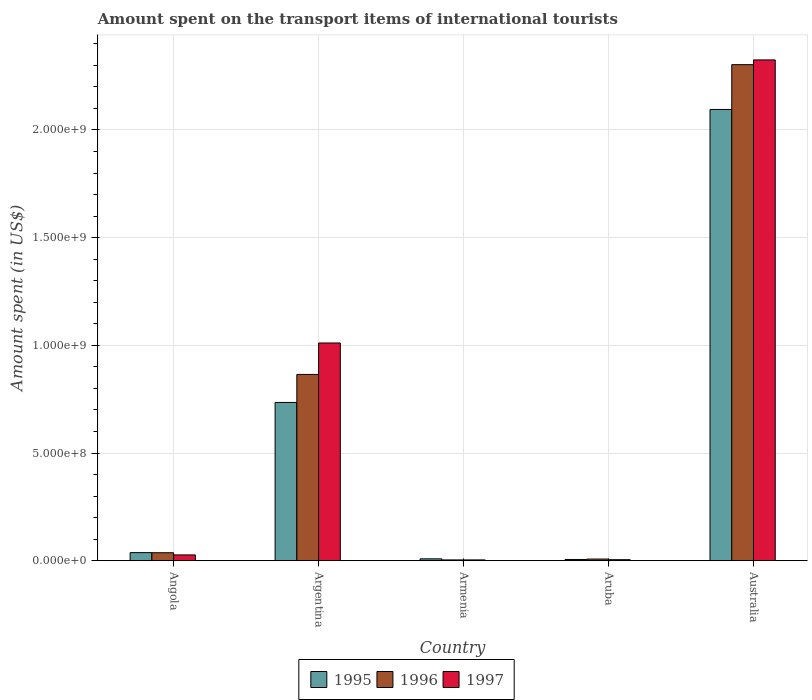How many different coloured bars are there?
Your response must be concise. 3. Are the number of bars on each tick of the X-axis equal?
Your answer should be very brief. Yes. How many bars are there on the 4th tick from the right?
Your answer should be compact. 3. What is the label of the 4th group of bars from the left?
Provide a succinct answer. Aruba. What is the amount spent on the transport items of international tourists in 1997 in Aruba?
Ensure brevity in your answer.  5.00e+06. Across all countries, what is the maximum amount spent on the transport items of international tourists in 1995?
Ensure brevity in your answer.  2.10e+09. Across all countries, what is the minimum amount spent on the transport items of international tourists in 1996?
Offer a terse response. 4.00e+06. In which country was the amount spent on the transport items of international tourists in 1995 minimum?
Provide a succinct answer. Aruba. What is the total amount spent on the transport items of international tourists in 1996 in the graph?
Ensure brevity in your answer.  3.22e+09. What is the difference between the amount spent on the transport items of international tourists in 1995 in Argentina and that in Aruba?
Offer a terse response. 7.29e+08. What is the difference between the amount spent on the transport items of international tourists in 1995 in Armenia and the amount spent on the transport items of international tourists in 1996 in Angola?
Keep it short and to the point. -2.84e+07. What is the average amount spent on the transport items of international tourists in 1996 per country?
Provide a short and direct response. 6.43e+08. What is the difference between the amount spent on the transport items of international tourists of/in 1996 and amount spent on the transport items of international tourists of/in 1995 in Armenia?
Provide a short and direct response. -5.00e+06. In how many countries, is the amount spent on the transport items of international tourists in 1995 greater than 2000000000 US$?
Offer a terse response. 1. What is the ratio of the amount spent on the transport items of international tourists in 1995 in Argentina to that in Armenia?
Your response must be concise. 81.67. Is the amount spent on the transport items of international tourists in 1997 in Angola less than that in Armenia?
Your response must be concise. No. What is the difference between the highest and the second highest amount spent on the transport items of international tourists in 1995?
Keep it short and to the point. 2.06e+09. What is the difference between the highest and the lowest amount spent on the transport items of international tourists in 1995?
Offer a very short reply. 2.09e+09. In how many countries, is the amount spent on the transport items of international tourists in 1995 greater than the average amount spent on the transport items of international tourists in 1995 taken over all countries?
Provide a succinct answer. 2. What does the 1st bar from the left in Aruba represents?
Ensure brevity in your answer.  1995. Is it the case that in every country, the sum of the amount spent on the transport items of international tourists in 1996 and amount spent on the transport items of international tourists in 1997 is greater than the amount spent on the transport items of international tourists in 1995?
Keep it short and to the point. No. Are all the bars in the graph horizontal?
Keep it short and to the point. No. How many countries are there in the graph?
Your answer should be compact. 5. What is the difference between two consecutive major ticks on the Y-axis?
Provide a short and direct response. 5.00e+08. Where does the legend appear in the graph?
Make the answer very short. Bottom center. How many legend labels are there?
Your answer should be very brief. 3. How are the legend labels stacked?
Provide a succinct answer. Horizontal. What is the title of the graph?
Offer a very short reply. Amount spent on the transport items of international tourists. Does "1967" appear as one of the legend labels in the graph?
Give a very brief answer. No. What is the label or title of the X-axis?
Make the answer very short. Country. What is the label or title of the Y-axis?
Provide a short and direct response. Amount spent (in US$). What is the Amount spent (in US$) in 1995 in Angola?
Your response must be concise. 3.78e+07. What is the Amount spent (in US$) in 1996 in Angola?
Your response must be concise. 3.74e+07. What is the Amount spent (in US$) of 1997 in Angola?
Provide a succinct answer. 2.72e+07. What is the Amount spent (in US$) of 1995 in Argentina?
Ensure brevity in your answer.  7.35e+08. What is the Amount spent (in US$) of 1996 in Argentina?
Provide a succinct answer. 8.65e+08. What is the Amount spent (in US$) of 1997 in Argentina?
Make the answer very short. 1.01e+09. What is the Amount spent (in US$) in 1995 in Armenia?
Ensure brevity in your answer.  9.00e+06. What is the Amount spent (in US$) in 1996 in Armenia?
Offer a terse response. 4.00e+06. What is the Amount spent (in US$) in 1995 in Aruba?
Offer a very short reply. 6.00e+06. What is the Amount spent (in US$) of 1996 in Aruba?
Keep it short and to the point. 8.00e+06. What is the Amount spent (in US$) of 1995 in Australia?
Offer a terse response. 2.10e+09. What is the Amount spent (in US$) in 1996 in Australia?
Provide a succinct answer. 2.30e+09. What is the Amount spent (in US$) of 1997 in Australia?
Provide a short and direct response. 2.32e+09. Across all countries, what is the maximum Amount spent (in US$) in 1995?
Your response must be concise. 2.10e+09. Across all countries, what is the maximum Amount spent (in US$) in 1996?
Your answer should be very brief. 2.30e+09. Across all countries, what is the maximum Amount spent (in US$) in 1997?
Give a very brief answer. 2.32e+09. Across all countries, what is the minimum Amount spent (in US$) of 1995?
Your response must be concise. 6.00e+06. Across all countries, what is the minimum Amount spent (in US$) of 1996?
Your answer should be very brief. 4.00e+06. Across all countries, what is the minimum Amount spent (in US$) of 1997?
Ensure brevity in your answer.  4.00e+06. What is the total Amount spent (in US$) of 1995 in the graph?
Offer a very short reply. 2.88e+09. What is the total Amount spent (in US$) of 1996 in the graph?
Ensure brevity in your answer.  3.22e+09. What is the total Amount spent (in US$) of 1997 in the graph?
Offer a terse response. 3.37e+09. What is the difference between the Amount spent (in US$) in 1995 in Angola and that in Argentina?
Your answer should be compact. -6.97e+08. What is the difference between the Amount spent (in US$) of 1996 in Angola and that in Argentina?
Your response must be concise. -8.28e+08. What is the difference between the Amount spent (in US$) of 1997 in Angola and that in Argentina?
Offer a very short reply. -9.84e+08. What is the difference between the Amount spent (in US$) of 1995 in Angola and that in Armenia?
Give a very brief answer. 2.88e+07. What is the difference between the Amount spent (in US$) in 1996 in Angola and that in Armenia?
Make the answer very short. 3.34e+07. What is the difference between the Amount spent (in US$) of 1997 in Angola and that in Armenia?
Your answer should be compact. 2.32e+07. What is the difference between the Amount spent (in US$) in 1995 in Angola and that in Aruba?
Ensure brevity in your answer.  3.18e+07. What is the difference between the Amount spent (in US$) in 1996 in Angola and that in Aruba?
Your answer should be compact. 2.94e+07. What is the difference between the Amount spent (in US$) of 1997 in Angola and that in Aruba?
Your answer should be compact. 2.22e+07. What is the difference between the Amount spent (in US$) of 1995 in Angola and that in Australia?
Offer a terse response. -2.06e+09. What is the difference between the Amount spent (in US$) in 1996 in Angola and that in Australia?
Provide a short and direct response. -2.27e+09. What is the difference between the Amount spent (in US$) of 1997 in Angola and that in Australia?
Provide a short and direct response. -2.30e+09. What is the difference between the Amount spent (in US$) in 1995 in Argentina and that in Armenia?
Give a very brief answer. 7.26e+08. What is the difference between the Amount spent (in US$) of 1996 in Argentina and that in Armenia?
Your answer should be very brief. 8.61e+08. What is the difference between the Amount spent (in US$) of 1997 in Argentina and that in Armenia?
Your answer should be compact. 1.01e+09. What is the difference between the Amount spent (in US$) of 1995 in Argentina and that in Aruba?
Provide a succinct answer. 7.29e+08. What is the difference between the Amount spent (in US$) of 1996 in Argentina and that in Aruba?
Provide a succinct answer. 8.57e+08. What is the difference between the Amount spent (in US$) in 1997 in Argentina and that in Aruba?
Ensure brevity in your answer.  1.01e+09. What is the difference between the Amount spent (in US$) of 1995 in Argentina and that in Australia?
Provide a short and direct response. -1.36e+09. What is the difference between the Amount spent (in US$) in 1996 in Argentina and that in Australia?
Your answer should be very brief. -1.44e+09. What is the difference between the Amount spent (in US$) in 1997 in Argentina and that in Australia?
Ensure brevity in your answer.  -1.31e+09. What is the difference between the Amount spent (in US$) in 1996 in Armenia and that in Aruba?
Ensure brevity in your answer.  -4.00e+06. What is the difference between the Amount spent (in US$) in 1997 in Armenia and that in Aruba?
Provide a succinct answer. -1.00e+06. What is the difference between the Amount spent (in US$) of 1995 in Armenia and that in Australia?
Provide a short and direct response. -2.09e+09. What is the difference between the Amount spent (in US$) of 1996 in Armenia and that in Australia?
Provide a short and direct response. -2.30e+09. What is the difference between the Amount spent (in US$) of 1997 in Armenia and that in Australia?
Provide a short and direct response. -2.32e+09. What is the difference between the Amount spent (in US$) in 1995 in Aruba and that in Australia?
Ensure brevity in your answer.  -2.09e+09. What is the difference between the Amount spent (in US$) in 1996 in Aruba and that in Australia?
Offer a very short reply. -2.30e+09. What is the difference between the Amount spent (in US$) of 1997 in Aruba and that in Australia?
Offer a very short reply. -2.32e+09. What is the difference between the Amount spent (in US$) of 1995 in Angola and the Amount spent (in US$) of 1996 in Argentina?
Provide a succinct answer. -8.27e+08. What is the difference between the Amount spent (in US$) of 1995 in Angola and the Amount spent (in US$) of 1997 in Argentina?
Make the answer very short. -9.73e+08. What is the difference between the Amount spent (in US$) of 1996 in Angola and the Amount spent (in US$) of 1997 in Argentina?
Offer a very short reply. -9.74e+08. What is the difference between the Amount spent (in US$) in 1995 in Angola and the Amount spent (in US$) in 1996 in Armenia?
Your answer should be compact. 3.38e+07. What is the difference between the Amount spent (in US$) in 1995 in Angola and the Amount spent (in US$) in 1997 in Armenia?
Make the answer very short. 3.38e+07. What is the difference between the Amount spent (in US$) of 1996 in Angola and the Amount spent (in US$) of 1997 in Armenia?
Ensure brevity in your answer.  3.34e+07. What is the difference between the Amount spent (in US$) of 1995 in Angola and the Amount spent (in US$) of 1996 in Aruba?
Offer a terse response. 2.98e+07. What is the difference between the Amount spent (in US$) in 1995 in Angola and the Amount spent (in US$) in 1997 in Aruba?
Your response must be concise. 3.28e+07. What is the difference between the Amount spent (in US$) in 1996 in Angola and the Amount spent (in US$) in 1997 in Aruba?
Keep it short and to the point. 3.24e+07. What is the difference between the Amount spent (in US$) of 1995 in Angola and the Amount spent (in US$) of 1996 in Australia?
Keep it short and to the point. -2.27e+09. What is the difference between the Amount spent (in US$) in 1995 in Angola and the Amount spent (in US$) in 1997 in Australia?
Your answer should be very brief. -2.29e+09. What is the difference between the Amount spent (in US$) in 1996 in Angola and the Amount spent (in US$) in 1997 in Australia?
Your answer should be very brief. -2.29e+09. What is the difference between the Amount spent (in US$) of 1995 in Argentina and the Amount spent (in US$) of 1996 in Armenia?
Offer a terse response. 7.31e+08. What is the difference between the Amount spent (in US$) of 1995 in Argentina and the Amount spent (in US$) of 1997 in Armenia?
Offer a terse response. 7.31e+08. What is the difference between the Amount spent (in US$) of 1996 in Argentina and the Amount spent (in US$) of 1997 in Armenia?
Your response must be concise. 8.61e+08. What is the difference between the Amount spent (in US$) in 1995 in Argentina and the Amount spent (in US$) in 1996 in Aruba?
Provide a short and direct response. 7.27e+08. What is the difference between the Amount spent (in US$) in 1995 in Argentina and the Amount spent (in US$) in 1997 in Aruba?
Provide a short and direct response. 7.30e+08. What is the difference between the Amount spent (in US$) of 1996 in Argentina and the Amount spent (in US$) of 1997 in Aruba?
Your response must be concise. 8.60e+08. What is the difference between the Amount spent (in US$) of 1995 in Argentina and the Amount spent (in US$) of 1996 in Australia?
Your response must be concise. -1.57e+09. What is the difference between the Amount spent (in US$) in 1995 in Argentina and the Amount spent (in US$) in 1997 in Australia?
Keep it short and to the point. -1.59e+09. What is the difference between the Amount spent (in US$) in 1996 in Argentina and the Amount spent (in US$) in 1997 in Australia?
Ensure brevity in your answer.  -1.46e+09. What is the difference between the Amount spent (in US$) in 1995 in Armenia and the Amount spent (in US$) in 1996 in Australia?
Offer a very short reply. -2.29e+09. What is the difference between the Amount spent (in US$) in 1995 in Armenia and the Amount spent (in US$) in 1997 in Australia?
Provide a short and direct response. -2.32e+09. What is the difference between the Amount spent (in US$) in 1996 in Armenia and the Amount spent (in US$) in 1997 in Australia?
Your answer should be very brief. -2.32e+09. What is the difference between the Amount spent (in US$) in 1995 in Aruba and the Amount spent (in US$) in 1996 in Australia?
Your answer should be very brief. -2.30e+09. What is the difference between the Amount spent (in US$) of 1995 in Aruba and the Amount spent (in US$) of 1997 in Australia?
Offer a terse response. -2.32e+09. What is the difference between the Amount spent (in US$) in 1996 in Aruba and the Amount spent (in US$) in 1997 in Australia?
Keep it short and to the point. -2.32e+09. What is the average Amount spent (in US$) of 1995 per country?
Your response must be concise. 5.77e+08. What is the average Amount spent (in US$) in 1996 per country?
Make the answer very short. 6.43e+08. What is the average Amount spent (in US$) in 1997 per country?
Keep it short and to the point. 6.74e+08. What is the difference between the Amount spent (in US$) of 1995 and Amount spent (in US$) of 1997 in Angola?
Provide a short and direct response. 1.06e+07. What is the difference between the Amount spent (in US$) of 1996 and Amount spent (in US$) of 1997 in Angola?
Give a very brief answer. 1.02e+07. What is the difference between the Amount spent (in US$) of 1995 and Amount spent (in US$) of 1996 in Argentina?
Make the answer very short. -1.30e+08. What is the difference between the Amount spent (in US$) of 1995 and Amount spent (in US$) of 1997 in Argentina?
Your answer should be compact. -2.76e+08. What is the difference between the Amount spent (in US$) of 1996 and Amount spent (in US$) of 1997 in Argentina?
Offer a very short reply. -1.46e+08. What is the difference between the Amount spent (in US$) in 1995 and Amount spent (in US$) in 1996 in Armenia?
Provide a succinct answer. 5.00e+06. What is the difference between the Amount spent (in US$) in 1996 and Amount spent (in US$) in 1997 in Armenia?
Offer a terse response. 0. What is the difference between the Amount spent (in US$) in 1996 and Amount spent (in US$) in 1997 in Aruba?
Offer a very short reply. 3.00e+06. What is the difference between the Amount spent (in US$) of 1995 and Amount spent (in US$) of 1996 in Australia?
Provide a short and direct response. -2.08e+08. What is the difference between the Amount spent (in US$) of 1995 and Amount spent (in US$) of 1997 in Australia?
Offer a very short reply. -2.30e+08. What is the difference between the Amount spent (in US$) of 1996 and Amount spent (in US$) of 1997 in Australia?
Make the answer very short. -2.20e+07. What is the ratio of the Amount spent (in US$) of 1995 in Angola to that in Argentina?
Make the answer very short. 0.05. What is the ratio of the Amount spent (in US$) of 1996 in Angola to that in Argentina?
Your answer should be very brief. 0.04. What is the ratio of the Amount spent (in US$) in 1997 in Angola to that in Argentina?
Your answer should be very brief. 0.03. What is the ratio of the Amount spent (in US$) in 1995 in Angola to that in Armenia?
Your response must be concise. 4.2. What is the ratio of the Amount spent (in US$) in 1996 in Angola to that in Armenia?
Ensure brevity in your answer.  9.34. What is the ratio of the Amount spent (in US$) of 1995 in Angola to that in Aruba?
Give a very brief answer. 6.3. What is the ratio of the Amount spent (in US$) of 1996 in Angola to that in Aruba?
Make the answer very short. 4.67. What is the ratio of the Amount spent (in US$) in 1997 in Angola to that in Aruba?
Your answer should be very brief. 5.44. What is the ratio of the Amount spent (in US$) of 1995 in Angola to that in Australia?
Offer a very short reply. 0.02. What is the ratio of the Amount spent (in US$) of 1996 in Angola to that in Australia?
Ensure brevity in your answer.  0.02. What is the ratio of the Amount spent (in US$) in 1997 in Angola to that in Australia?
Give a very brief answer. 0.01. What is the ratio of the Amount spent (in US$) in 1995 in Argentina to that in Armenia?
Ensure brevity in your answer.  81.67. What is the ratio of the Amount spent (in US$) of 1996 in Argentina to that in Armenia?
Offer a very short reply. 216.25. What is the ratio of the Amount spent (in US$) of 1997 in Argentina to that in Armenia?
Make the answer very short. 252.75. What is the ratio of the Amount spent (in US$) of 1995 in Argentina to that in Aruba?
Your answer should be compact. 122.5. What is the ratio of the Amount spent (in US$) of 1996 in Argentina to that in Aruba?
Your answer should be very brief. 108.12. What is the ratio of the Amount spent (in US$) in 1997 in Argentina to that in Aruba?
Ensure brevity in your answer.  202.2. What is the ratio of the Amount spent (in US$) of 1995 in Argentina to that in Australia?
Your answer should be compact. 0.35. What is the ratio of the Amount spent (in US$) in 1996 in Argentina to that in Australia?
Keep it short and to the point. 0.38. What is the ratio of the Amount spent (in US$) of 1997 in Argentina to that in Australia?
Your answer should be compact. 0.43. What is the ratio of the Amount spent (in US$) in 1995 in Armenia to that in Aruba?
Ensure brevity in your answer.  1.5. What is the ratio of the Amount spent (in US$) in 1997 in Armenia to that in Aruba?
Provide a succinct answer. 0.8. What is the ratio of the Amount spent (in US$) in 1995 in Armenia to that in Australia?
Give a very brief answer. 0. What is the ratio of the Amount spent (in US$) of 1996 in Armenia to that in Australia?
Offer a very short reply. 0. What is the ratio of the Amount spent (in US$) in 1997 in Armenia to that in Australia?
Offer a very short reply. 0. What is the ratio of the Amount spent (in US$) in 1995 in Aruba to that in Australia?
Your response must be concise. 0. What is the ratio of the Amount spent (in US$) of 1996 in Aruba to that in Australia?
Provide a succinct answer. 0. What is the ratio of the Amount spent (in US$) in 1997 in Aruba to that in Australia?
Your answer should be compact. 0. What is the difference between the highest and the second highest Amount spent (in US$) of 1995?
Keep it short and to the point. 1.36e+09. What is the difference between the highest and the second highest Amount spent (in US$) of 1996?
Make the answer very short. 1.44e+09. What is the difference between the highest and the second highest Amount spent (in US$) of 1997?
Your response must be concise. 1.31e+09. What is the difference between the highest and the lowest Amount spent (in US$) in 1995?
Your answer should be very brief. 2.09e+09. What is the difference between the highest and the lowest Amount spent (in US$) in 1996?
Give a very brief answer. 2.30e+09. What is the difference between the highest and the lowest Amount spent (in US$) in 1997?
Ensure brevity in your answer.  2.32e+09. 